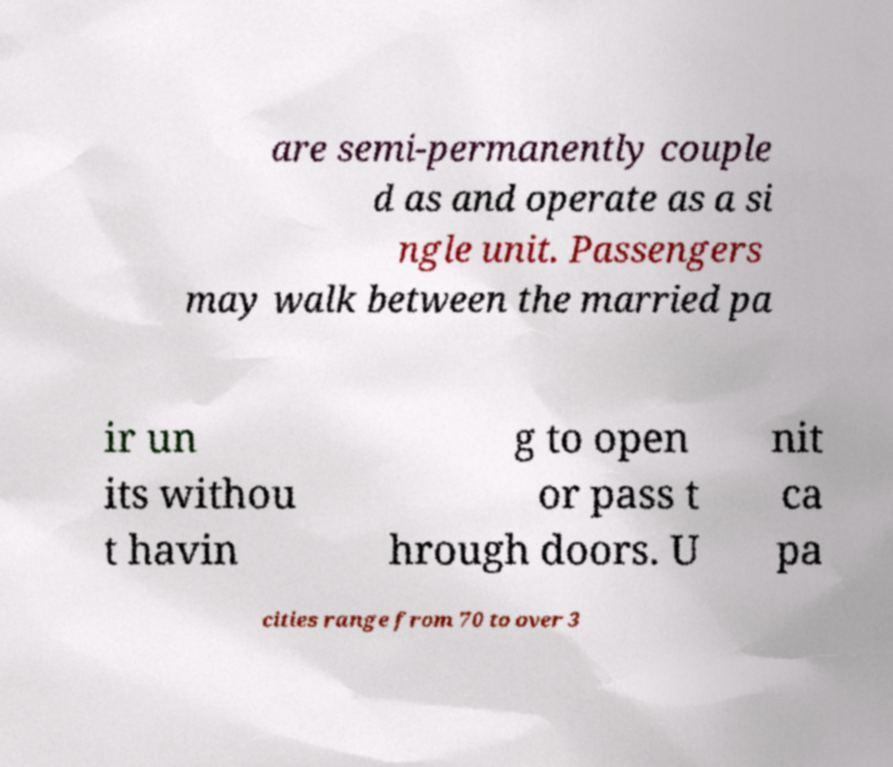Please identify and transcribe the text found in this image. are semi-permanently couple d as and operate as a si ngle unit. Passengers may walk between the married pa ir un its withou t havin g to open or pass t hrough doors. U nit ca pa cities range from 70 to over 3 